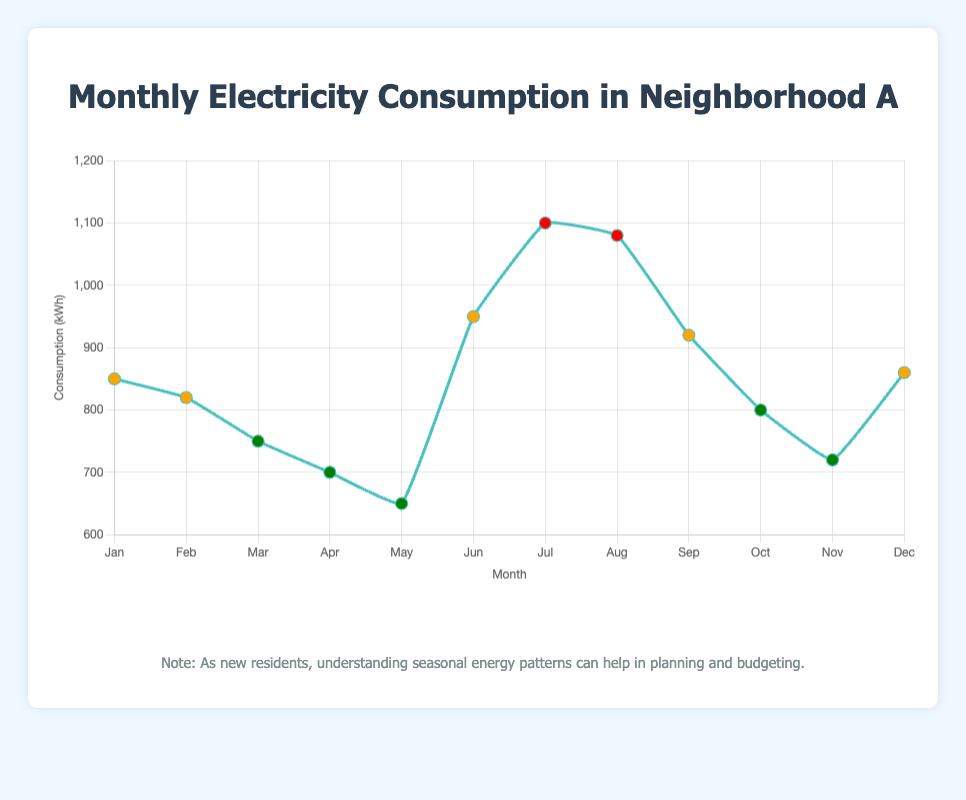Which month had the highest electricity consumption? The highest consumption value can be identified by looking at the tallest point in the line plot. July has the highest point with 1100 kWh.
Answer: July Which months are part of the summer season and how does their electricity consumption compare? Identify the summer months (June, July, August) and compare their values: June (950 kWh), July (1100 kWh), August (1080 kWh). July is the highest, followed by August, then June.
Answer: July > August > June What's the average electricity consumption for the winter months? Winter months are January (850 kWh), February (820 kWh), and December (860 kWh). Sum these values (850 + 820 + 860 = 2530) and divide by 3 (2530 / 3 ≈ 843.33).
Answer: 843.33 kWh Between which two consecutive months is the largest increase in electricity consumption observed? Compare the differences between consecutive months: March-April (750-700=50), April-May (700-650=50), May-June (650-950=300), June-July (950-1100=150), July-August (1100-1080=-20). The largest increase is from May to June with an increase of 300 kWh.
Answer: May to June What is the difference in electricity consumption between the highest and lowest months? The highest consumption (July, 1100 kWh) and the lowest (May, 650 kWh). Subtract the two (1100 - 650 = 450 kWh).
Answer: 450 kWh In which seasons do the months with electricity consumption greater than 1000 kWh fall? Identify the months with consumption >1000 kWh: July (1100 kWh) and August (1080 kWh). Both months fall in summer.
Answer: Summer Which month shows the sharpest drop in electricity consumption compared to the previous month? Evaluate each drop: From June to July is -150 kWh, and from August to September is -160 kWh, among others. The sharpest drop is from August to September (1080-920=160 kWh).
Answer: August to September What is the sum of electricity consumption for the spring season? Spring months are March (750 kWh), April (700 kWh), and May (650 kWh). Adding these values gives 750 + 700 + 650 = 2100 kWh.
Answer: 2100 kWh How does the electricity consumption in January compare to that in December? January consumption (850 kWh) and December (860 kWh). January is slightly lower than December (850 < 860).
Answer: January < December 